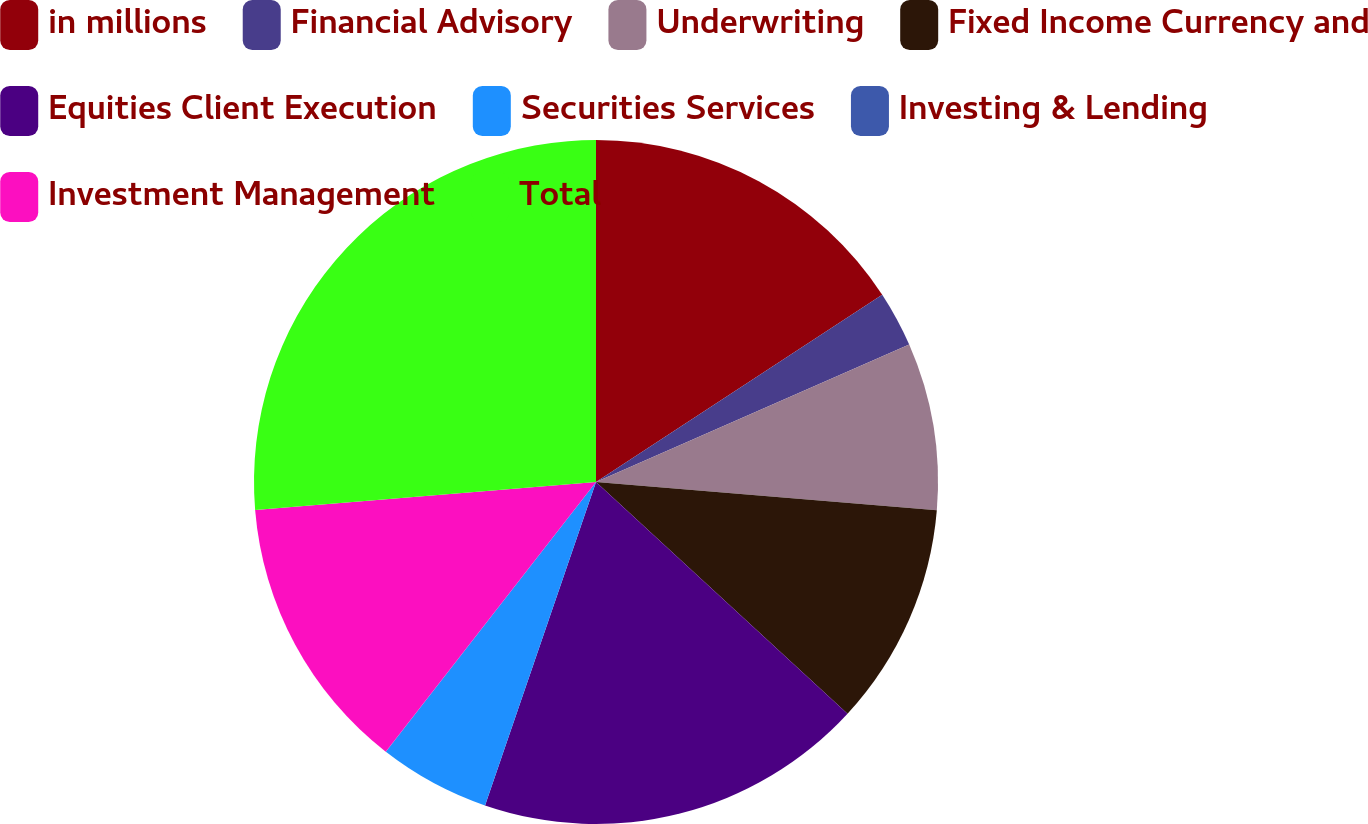Convert chart. <chart><loc_0><loc_0><loc_500><loc_500><pie_chart><fcel>in millions<fcel>Financial Advisory<fcel>Underwriting<fcel>Fixed Income Currency and<fcel>Equities Client Execution<fcel>Securities Services<fcel>Investing & Lending<fcel>Investment Management<fcel>Total<nl><fcel>15.78%<fcel>2.64%<fcel>7.9%<fcel>10.53%<fcel>18.41%<fcel>5.27%<fcel>0.01%<fcel>13.16%<fcel>26.3%<nl></chart> 